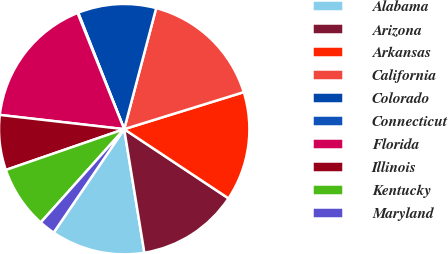Convert chart. <chart><loc_0><loc_0><loc_500><loc_500><pie_chart><fcel>Alabama<fcel>Arizona<fcel>Arkansas<fcel>California<fcel>Colorado<fcel>Connecticut<fcel>Florida<fcel>Illinois<fcel>Kentucky<fcel>Maryland<nl><fcel>12.1%<fcel>13.1%<fcel>14.1%<fcel>16.11%<fcel>10.1%<fcel>0.09%<fcel>17.11%<fcel>7.1%<fcel>8.1%<fcel>2.09%<nl></chart> 